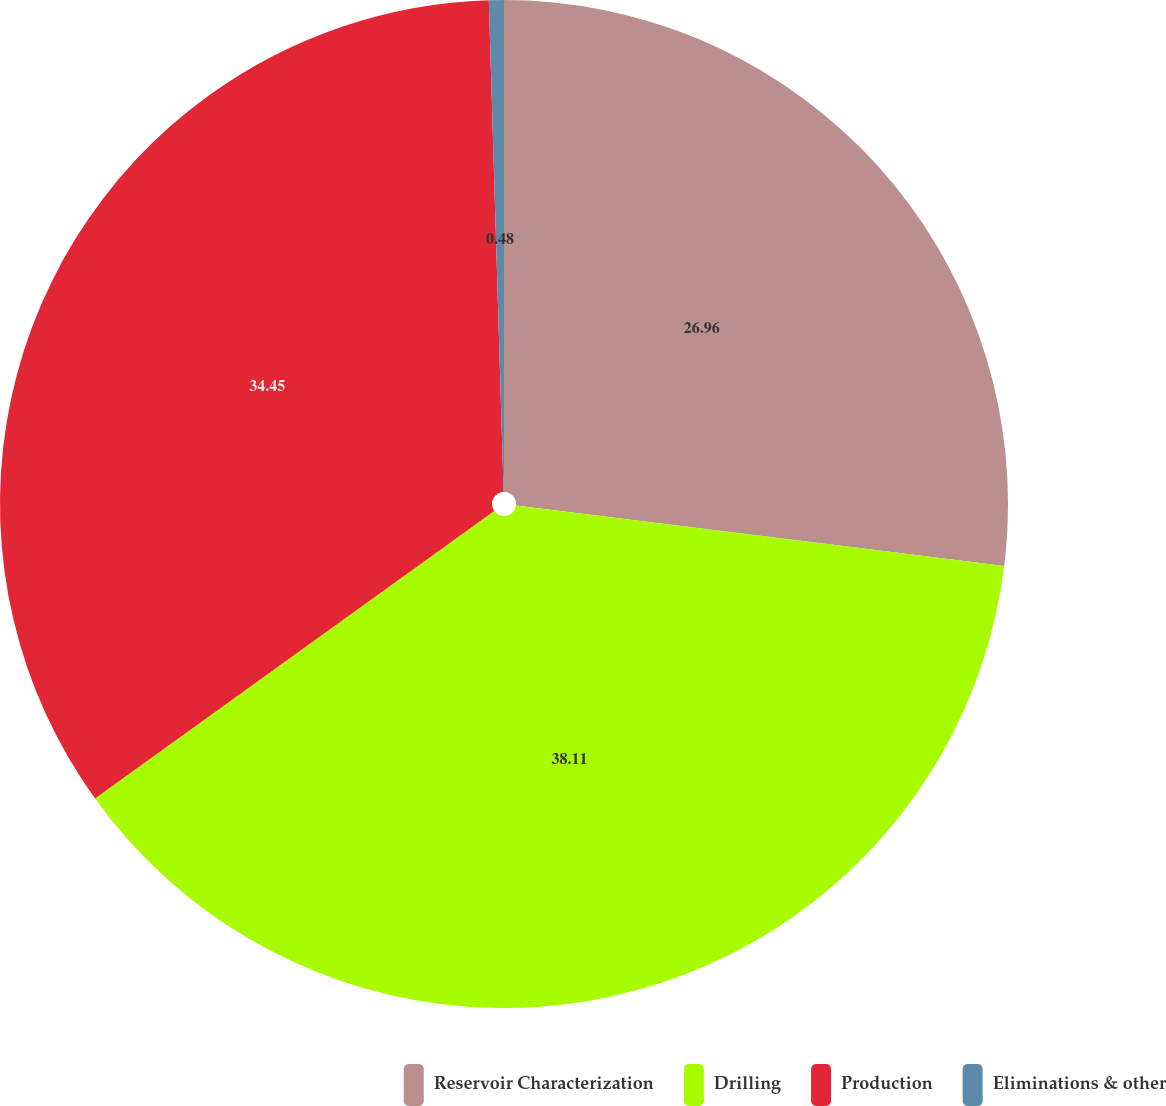<chart> <loc_0><loc_0><loc_500><loc_500><pie_chart><fcel>Reservoir Characterization<fcel>Drilling<fcel>Production<fcel>Eliminations & other<nl><fcel>26.96%<fcel>38.1%<fcel>34.45%<fcel>0.48%<nl></chart> 